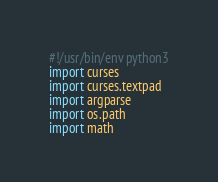<code> <loc_0><loc_0><loc_500><loc_500><_Python_>#!/usr/bin/env python3
import curses
import curses.textpad
import argparse
import os.path
import math
</code> 